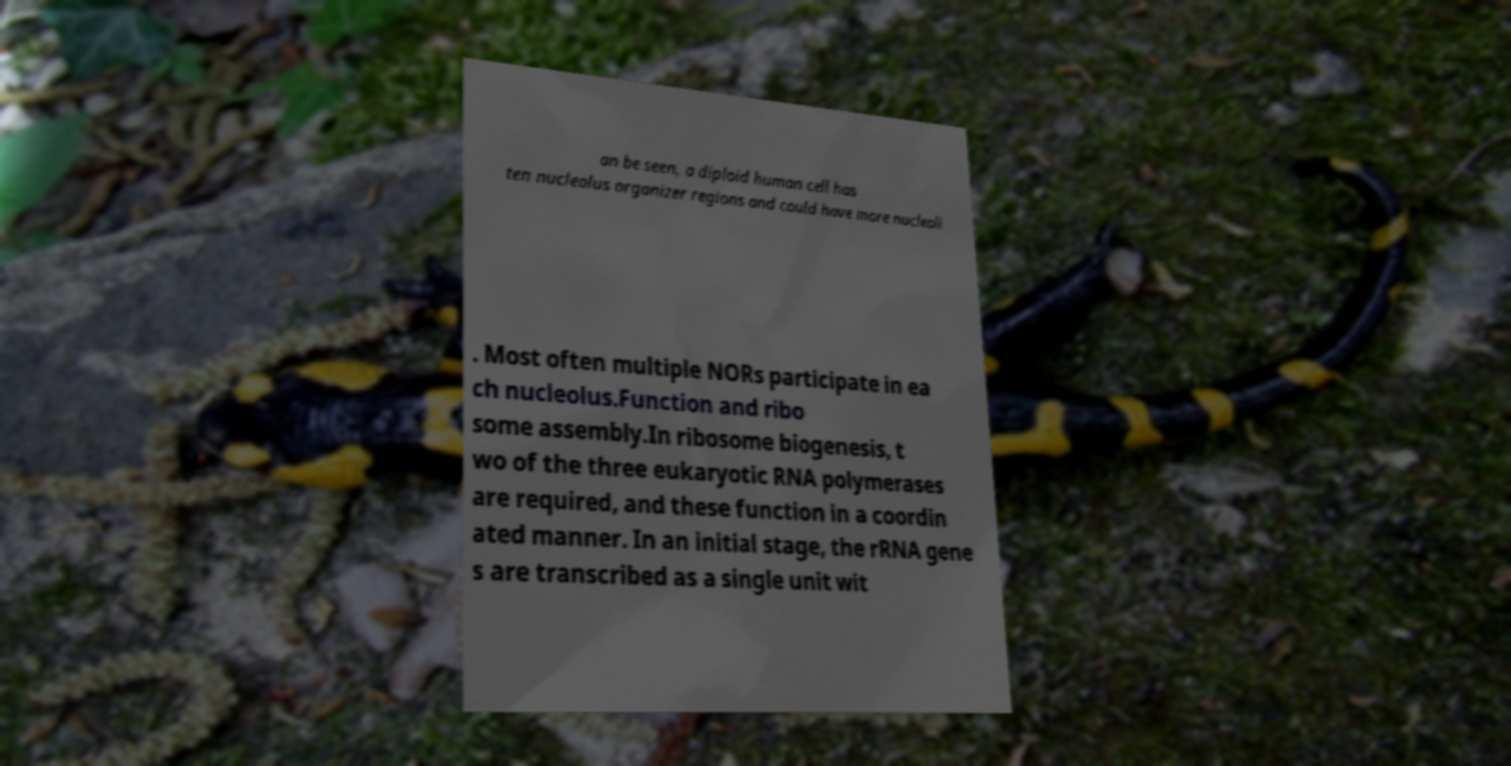Could you assist in decoding the text presented in this image and type it out clearly? an be seen, a diploid human cell has ten nucleolus organizer regions and could have more nucleoli . Most often multiple NORs participate in ea ch nucleolus.Function and ribo some assembly.In ribosome biogenesis, t wo of the three eukaryotic RNA polymerases are required, and these function in a coordin ated manner. In an initial stage, the rRNA gene s are transcribed as a single unit wit 